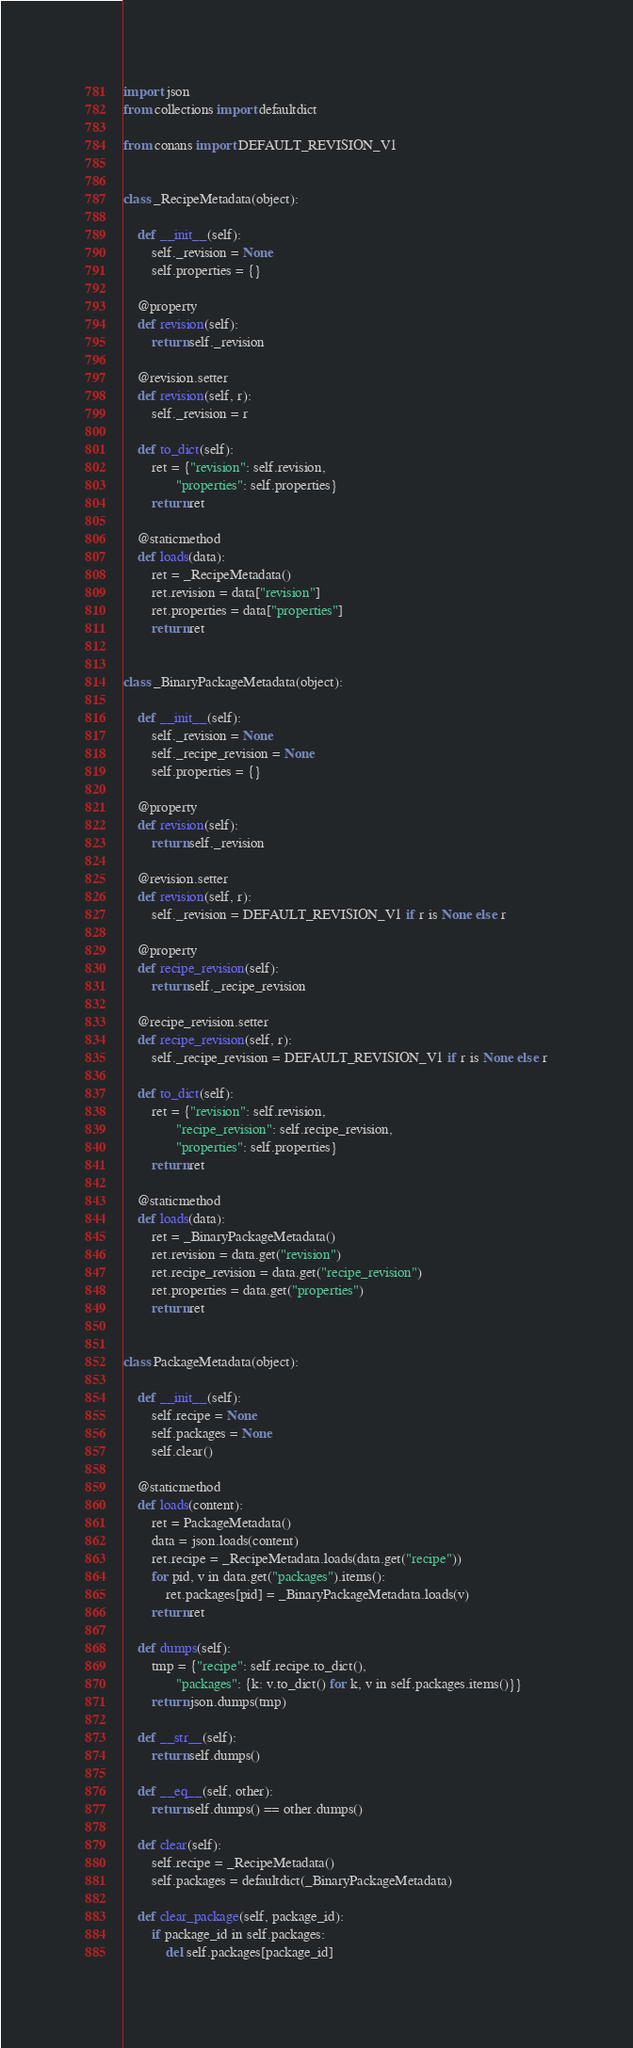<code> <loc_0><loc_0><loc_500><loc_500><_Python_>import json
from collections import defaultdict

from conans import DEFAULT_REVISION_V1


class _RecipeMetadata(object):

    def __init__(self):
        self._revision = None
        self.properties = {}

    @property
    def revision(self):
        return self._revision

    @revision.setter
    def revision(self, r):
        self._revision = r

    def to_dict(self):
        ret = {"revision": self.revision,
               "properties": self.properties}
        return ret

    @staticmethod
    def loads(data):
        ret = _RecipeMetadata()
        ret.revision = data["revision"]
        ret.properties = data["properties"]
        return ret


class _BinaryPackageMetadata(object):

    def __init__(self):
        self._revision = None
        self._recipe_revision = None
        self.properties = {}

    @property
    def revision(self):
        return self._revision

    @revision.setter
    def revision(self, r):
        self._revision = DEFAULT_REVISION_V1 if r is None else r

    @property
    def recipe_revision(self):
        return self._recipe_revision

    @recipe_revision.setter
    def recipe_revision(self, r):
        self._recipe_revision = DEFAULT_REVISION_V1 if r is None else r

    def to_dict(self):
        ret = {"revision": self.revision,
               "recipe_revision": self.recipe_revision,
               "properties": self.properties}
        return ret

    @staticmethod
    def loads(data):
        ret = _BinaryPackageMetadata()
        ret.revision = data.get("revision")
        ret.recipe_revision = data.get("recipe_revision")
        ret.properties = data.get("properties")
        return ret


class PackageMetadata(object):

    def __init__(self):
        self.recipe = None
        self.packages = None
        self.clear()

    @staticmethod
    def loads(content):
        ret = PackageMetadata()
        data = json.loads(content)
        ret.recipe = _RecipeMetadata.loads(data.get("recipe"))
        for pid, v in data.get("packages").items():
            ret.packages[pid] = _BinaryPackageMetadata.loads(v)
        return ret

    def dumps(self):
        tmp = {"recipe": self.recipe.to_dict(),
               "packages": {k: v.to_dict() for k, v in self.packages.items()}}
        return json.dumps(tmp)

    def __str__(self):
        return self.dumps()

    def __eq__(self, other):
        return self.dumps() == other.dumps()

    def clear(self):
        self.recipe = _RecipeMetadata()
        self.packages = defaultdict(_BinaryPackageMetadata)

    def clear_package(self, package_id):
        if package_id in self.packages:
            del self.packages[package_id]
</code> 